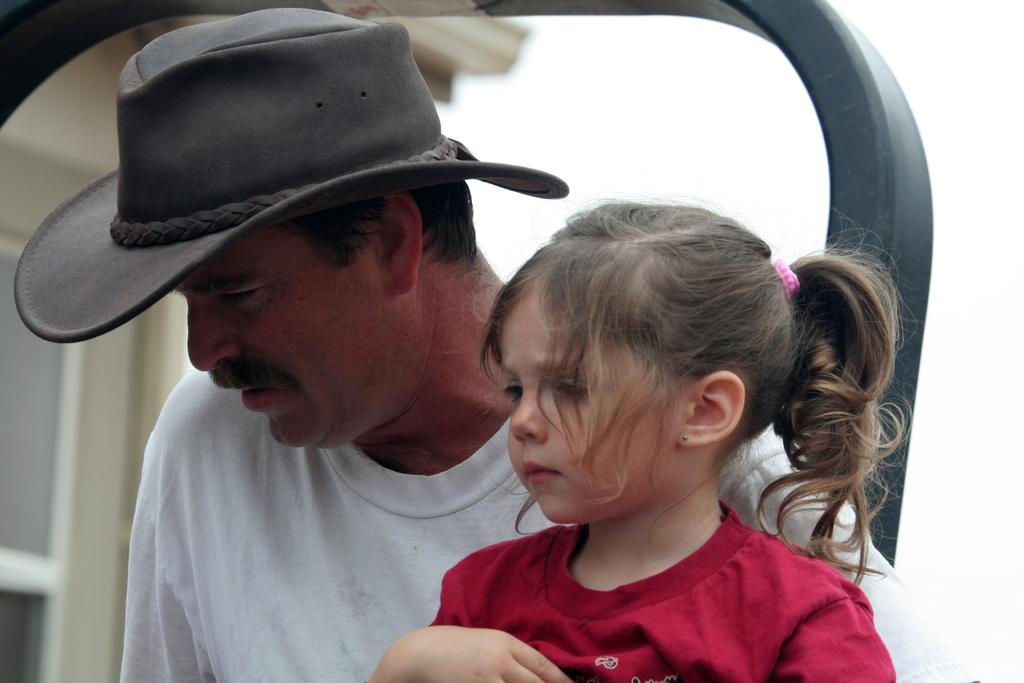Who is the main subject in the center of the image? There is a girl in the center of the image. What is the girl wearing in the image? There is a person wearing a hat in the center of the image. What can be seen in the background of the image? There is a building in the background of the image. What is visible above the building in the image? The sky is visible in the background of the image. What type of wood is the camera made of in the image? There is no camera present in the image, so it is not possible to determine what type of wood it might be made of. 